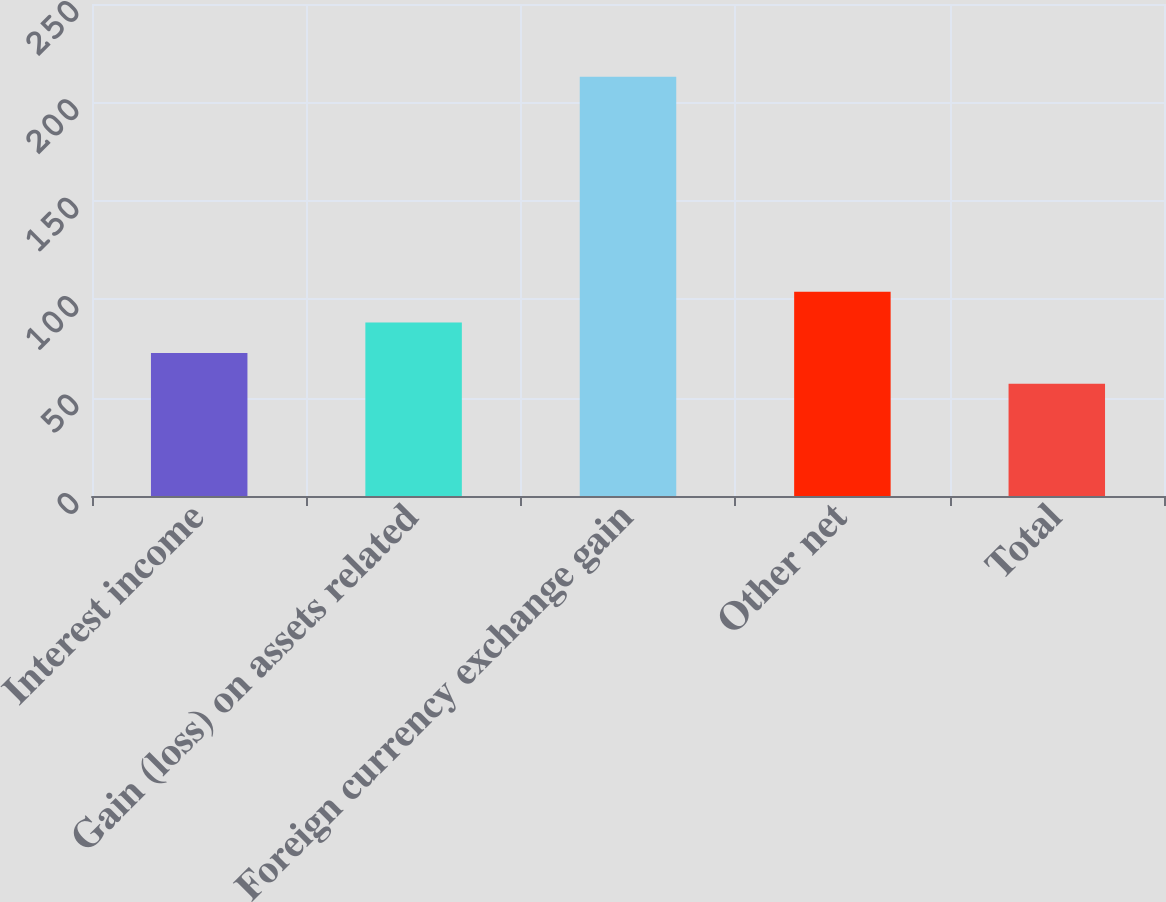Convert chart to OTSL. <chart><loc_0><loc_0><loc_500><loc_500><bar_chart><fcel>Interest income<fcel>Gain (loss) on assets related<fcel>Foreign currency exchange gain<fcel>Other net<fcel>Total<nl><fcel>72.6<fcel>88.2<fcel>213<fcel>103.8<fcel>57<nl></chart> 